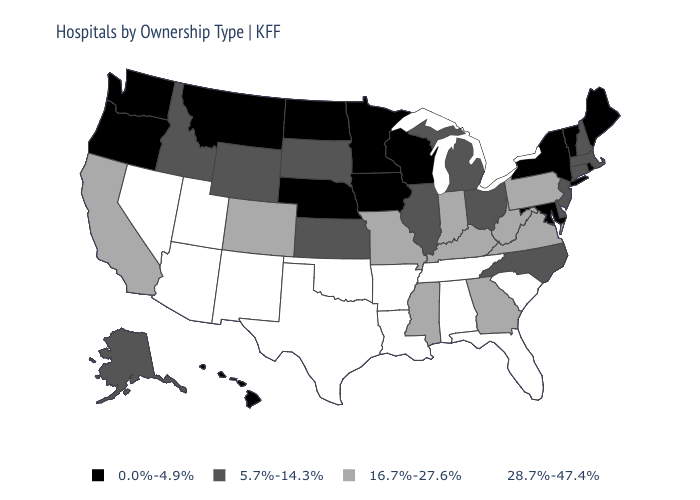Name the states that have a value in the range 28.7%-47.4%?
Give a very brief answer. Alabama, Arizona, Arkansas, Florida, Louisiana, Nevada, New Mexico, Oklahoma, South Carolina, Tennessee, Texas, Utah. Name the states that have a value in the range 28.7%-47.4%?
Concise answer only. Alabama, Arizona, Arkansas, Florida, Louisiana, Nevada, New Mexico, Oklahoma, South Carolina, Tennessee, Texas, Utah. What is the lowest value in the USA?
Short answer required. 0.0%-4.9%. Does Hawaii have the highest value in the West?
Keep it brief. No. Which states have the highest value in the USA?
Write a very short answer. Alabama, Arizona, Arkansas, Florida, Louisiana, Nevada, New Mexico, Oklahoma, South Carolina, Tennessee, Texas, Utah. What is the value of Missouri?
Answer briefly. 16.7%-27.6%. Among the states that border Wisconsin , does Illinois have the lowest value?
Write a very short answer. No. Name the states that have a value in the range 5.7%-14.3%?
Give a very brief answer. Alaska, Connecticut, Delaware, Idaho, Illinois, Kansas, Massachusetts, Michigan, New Hampshire, New Jersey, North Carolina, Ohio, South Dakota, Wyoming. Does the first symbol in the legend represent the smallest category?
Quick response, please. Yes. Name the states that have a value in the range 0.0%-4.9%?
Give a very brief answer. Hawaii, Iowa, Maine, Maryland, Minnesota, Montana, Nebraska, New York, North Dakota, Oregon, Rhode Island, Vermont, Washington, Wisconsin. What is the value of Maryland?
Concise answer only. 0.0%-4.9%. Does Maryland have the lowest value in the South?
Be succinct. Yes. What is the highest value in the South ?
Short answer required. 28.7%-47.4%. Is the legend a continuous bar?
Keep it brief. No. What is the lowest value in the USA?
Write a very short answer. 0.0%-4.9%. 